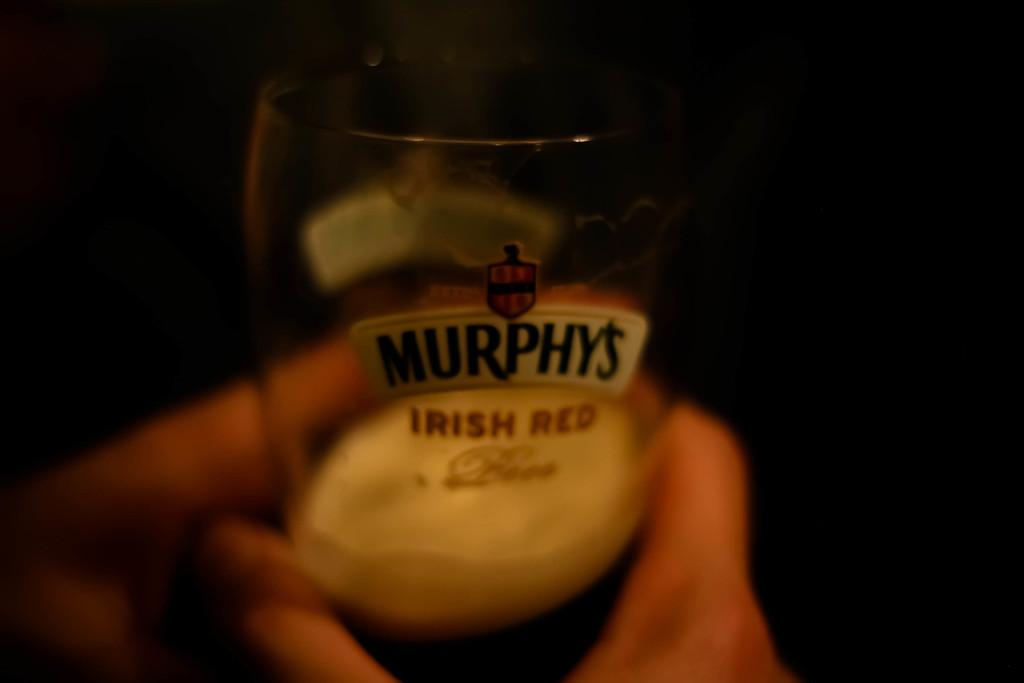Provide a one-sentence caption for the provided image. a shot glass labeled with the logo of "Murphys Irish Red". 